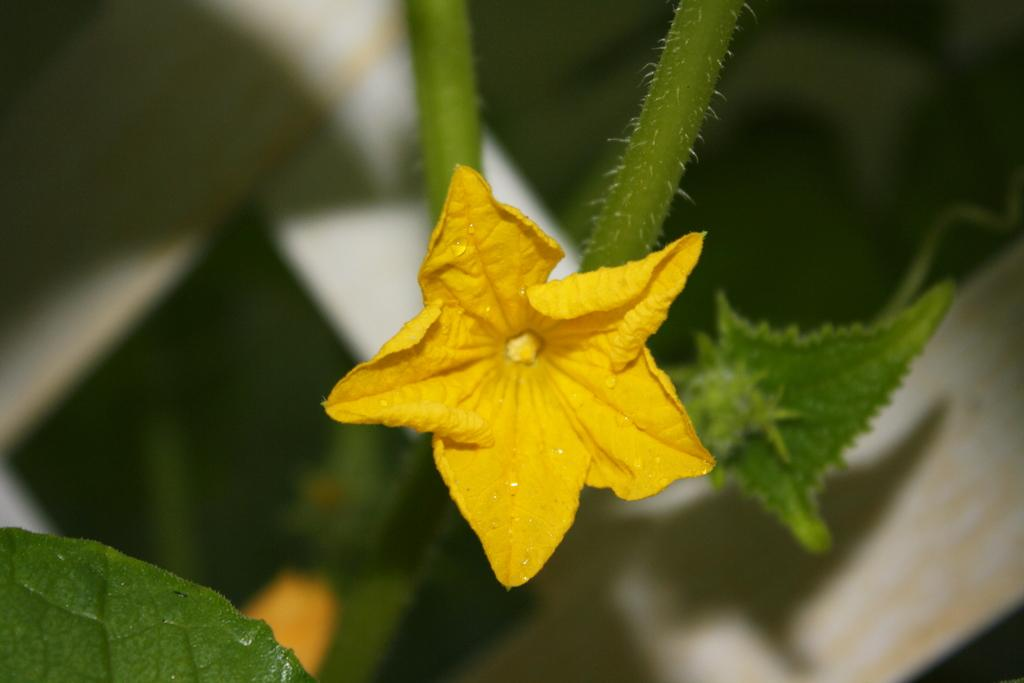What type of plant can be seen in the image? There is a flower and leaves in the image, which suggests that there is a plant present. What other elements are visible in the image besides the plant? The background of the image is blurry. What color is the comfort in the image? There is no comfort present in the image, as it is a photograph of a plant with a blurry background. 